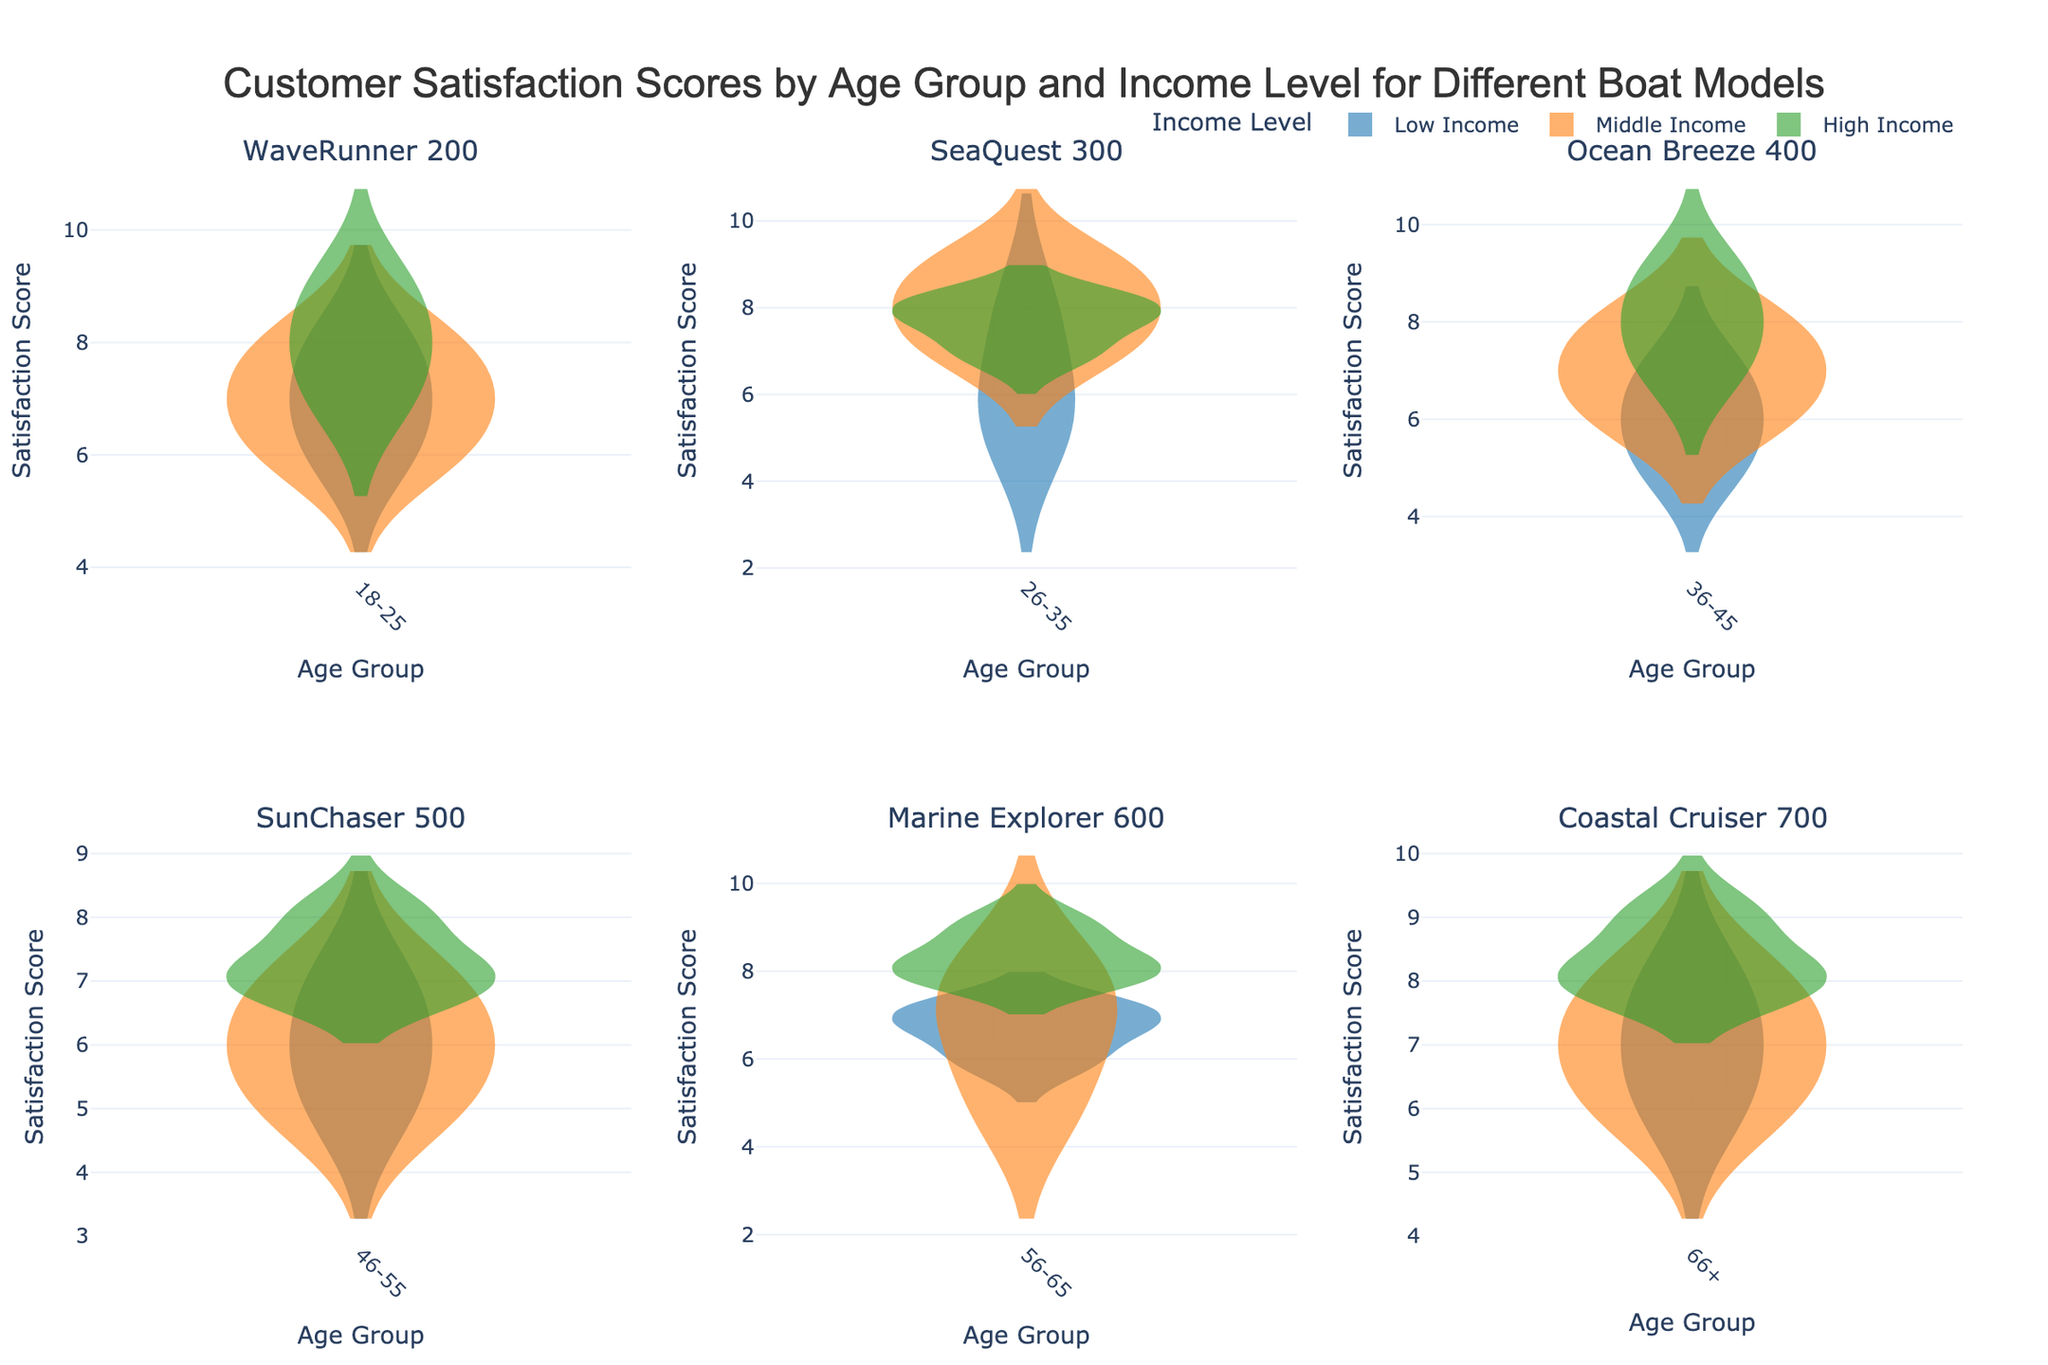What is the title of the figure? The title is located at the top of the figure and clearly states what the figure is about. It reads "Customer Satisfaction Scores by Age Group and Income Level for Different Boat Models."
Answer: Customer Satisfaction Scores by Age Group and Income Level for Different Boat Models What do the colors represent in the violin plots? The legend at the top of the figure indicates that the colors represent different income levels: Low Income, Middle Income, and High Income.
Answer: Income levels Which boat model has the highest median satisfaction score for the 18-25 age group? By looking at the median line within the violins for each boat model in the 18-25 age group, we see that the 'WaveRunner 200' has the highest median score.
Answer: WaveRunner 200 How do satisfaction scores for the SeaQuest 300 model differ between Middle and High income levels in the 26-35 age group? Comparing the violins for Middle and High Income levels in the SeaQuest 300 sub-plot for ages 26-35, the median satisfaction scores are slightly higher for the Middle Income compared to High Income.
Answer: Middle Income is slightly higher What is the range of satisfaction scores for the Ocean Breeze 400 for the 36-45 age group? Within the sub-plot for the Ocean Breeze 400 model in the 36-45 age group, the range can be observed by identifying the lowest and highest points in the violins. The scores range from 5 to 9.
Answer: 5 to 9 Which income level shows the most variability in satisfaction scores for the SunChaser 500 model in the 46-55 age group? The width of the violin plot indicates variability. The Low Income level has the most spread in satisfaction scores for the SunChaser 500 model in the 46-55 age group.
Answer: Low Income Are higher income customers generally more satisfied across all boat models? By generally comparing the position of the median lines and overall spread for High Income across all sub-plots, it appears that higher income customers tend to have higher satisfaction scores.
Answer: Yes Which boat model has the least variability in satisfaction scores for High Income customers? By examining the narrowest violin plot for High Income across all boat models, we see that the 'SunChaser 500' has the least variability.
Answer: SunChaser 500 What is the median satisfaction score for Marine Explorer 600 for the 56-65 age group and High Income level? The median line within the High Income violin plot for the Marine Explorer 600 model in the 56-65 age group indicates the median satisfaction score. It is 8.
Answer: 8 For the Coastal Cruiser 700 model, which age group and income level combination has the highest satisfaction score? The highest point in the violin plots for Coastal Cruiser 700 model shows that High Income customers in the 66+ age group have the highest satisfaction score of 9.
Answer: High Income, 66+ age group 